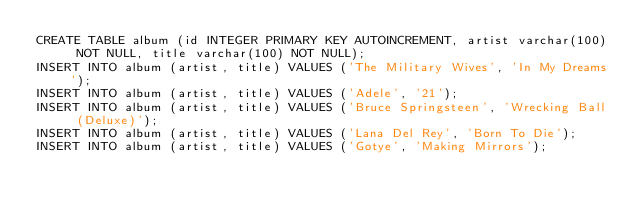Convert code to text. <code><loc_0><loc_0><loc_500><loc_500><_SQL_>CREATE TABLE album (id INTEGER PRIMARY KEY AUTOINCREMENT, artist varchar(100) NOT NULL, title varchar(100) NOT NULL);
INSERT INTO album (artist, title) VALUES ('The Military Wives', 'In My Dreams');
INSERT INTO album (artist, title) VALUES ('Adele', '21');
INSERT INTO album (artist, title) VALUES ('Bruce Springsteen', 'Wrecking Ball (Deluxe)');
INSERT INTO album (artist, title) VALUES ('Lana Del Rey', 'Born To Die');
INSERT INTO album (artist, title) VALUES ('Gotye', 'Making Mirrors');

</code> 